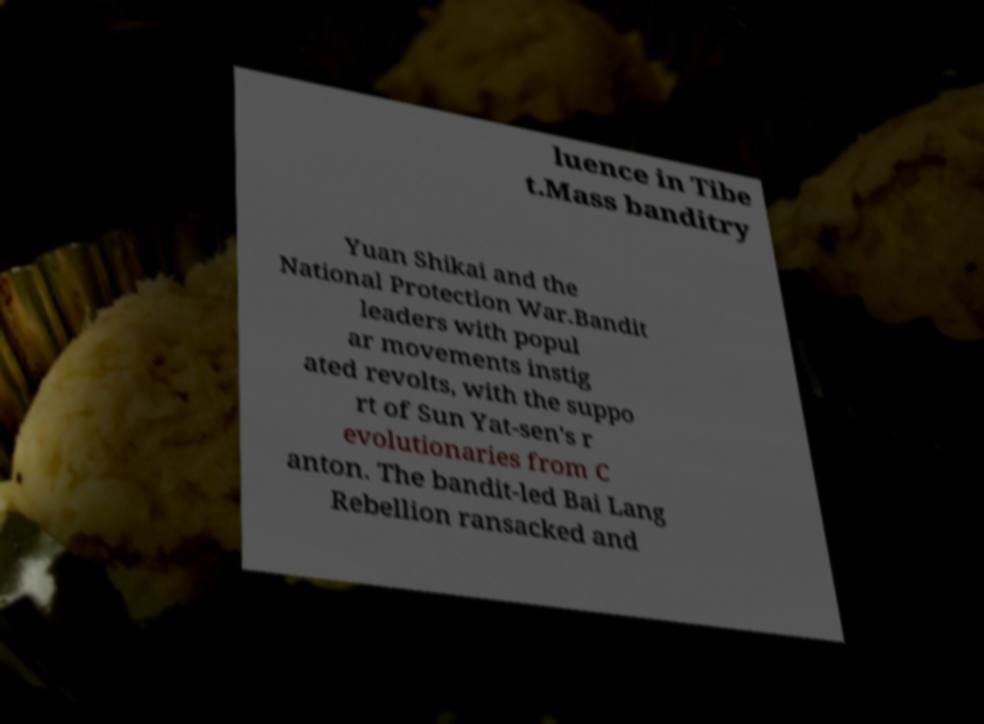Can you accurately transcribe the text from the provided image for me? luence in Tibe t.Mass banditry Yuan Shikai and the National Protection War.Bandit leaders with popul ar movements instig ated revolts, with the suppo rt of Sun Yat-sen's r evolutionaries from C anton. The bandit-led Bai Lang Rebellion ransacked and 